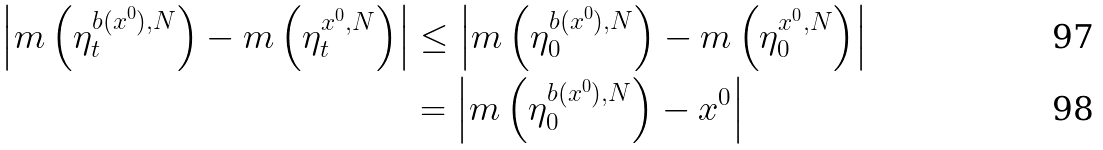Convert formula to latex. <formula><loc_0><loc_0><loc_500><loc_500>\left | m \left ( \eta _ { t } ^ { b ( x ^ { 0 } ) , N } \right ) - m \left ( \eta _ { t } ^ { x ^ { 0 } , N } \right ) \right | & \leq \left | m \left ( \eta _ { 0 } ^ { b ( x ^ { 0 } ) , N } \right ) - m \left ( \eta _ { 0 } ^ { x ^ { 0 } , N } \right ) \right | \\ & = \left | m \left ( \eta _ { 0 } ^ { b ( x ^ { 0 } ) , N } \right ) - x ^ { 0 } \right |</formula> 